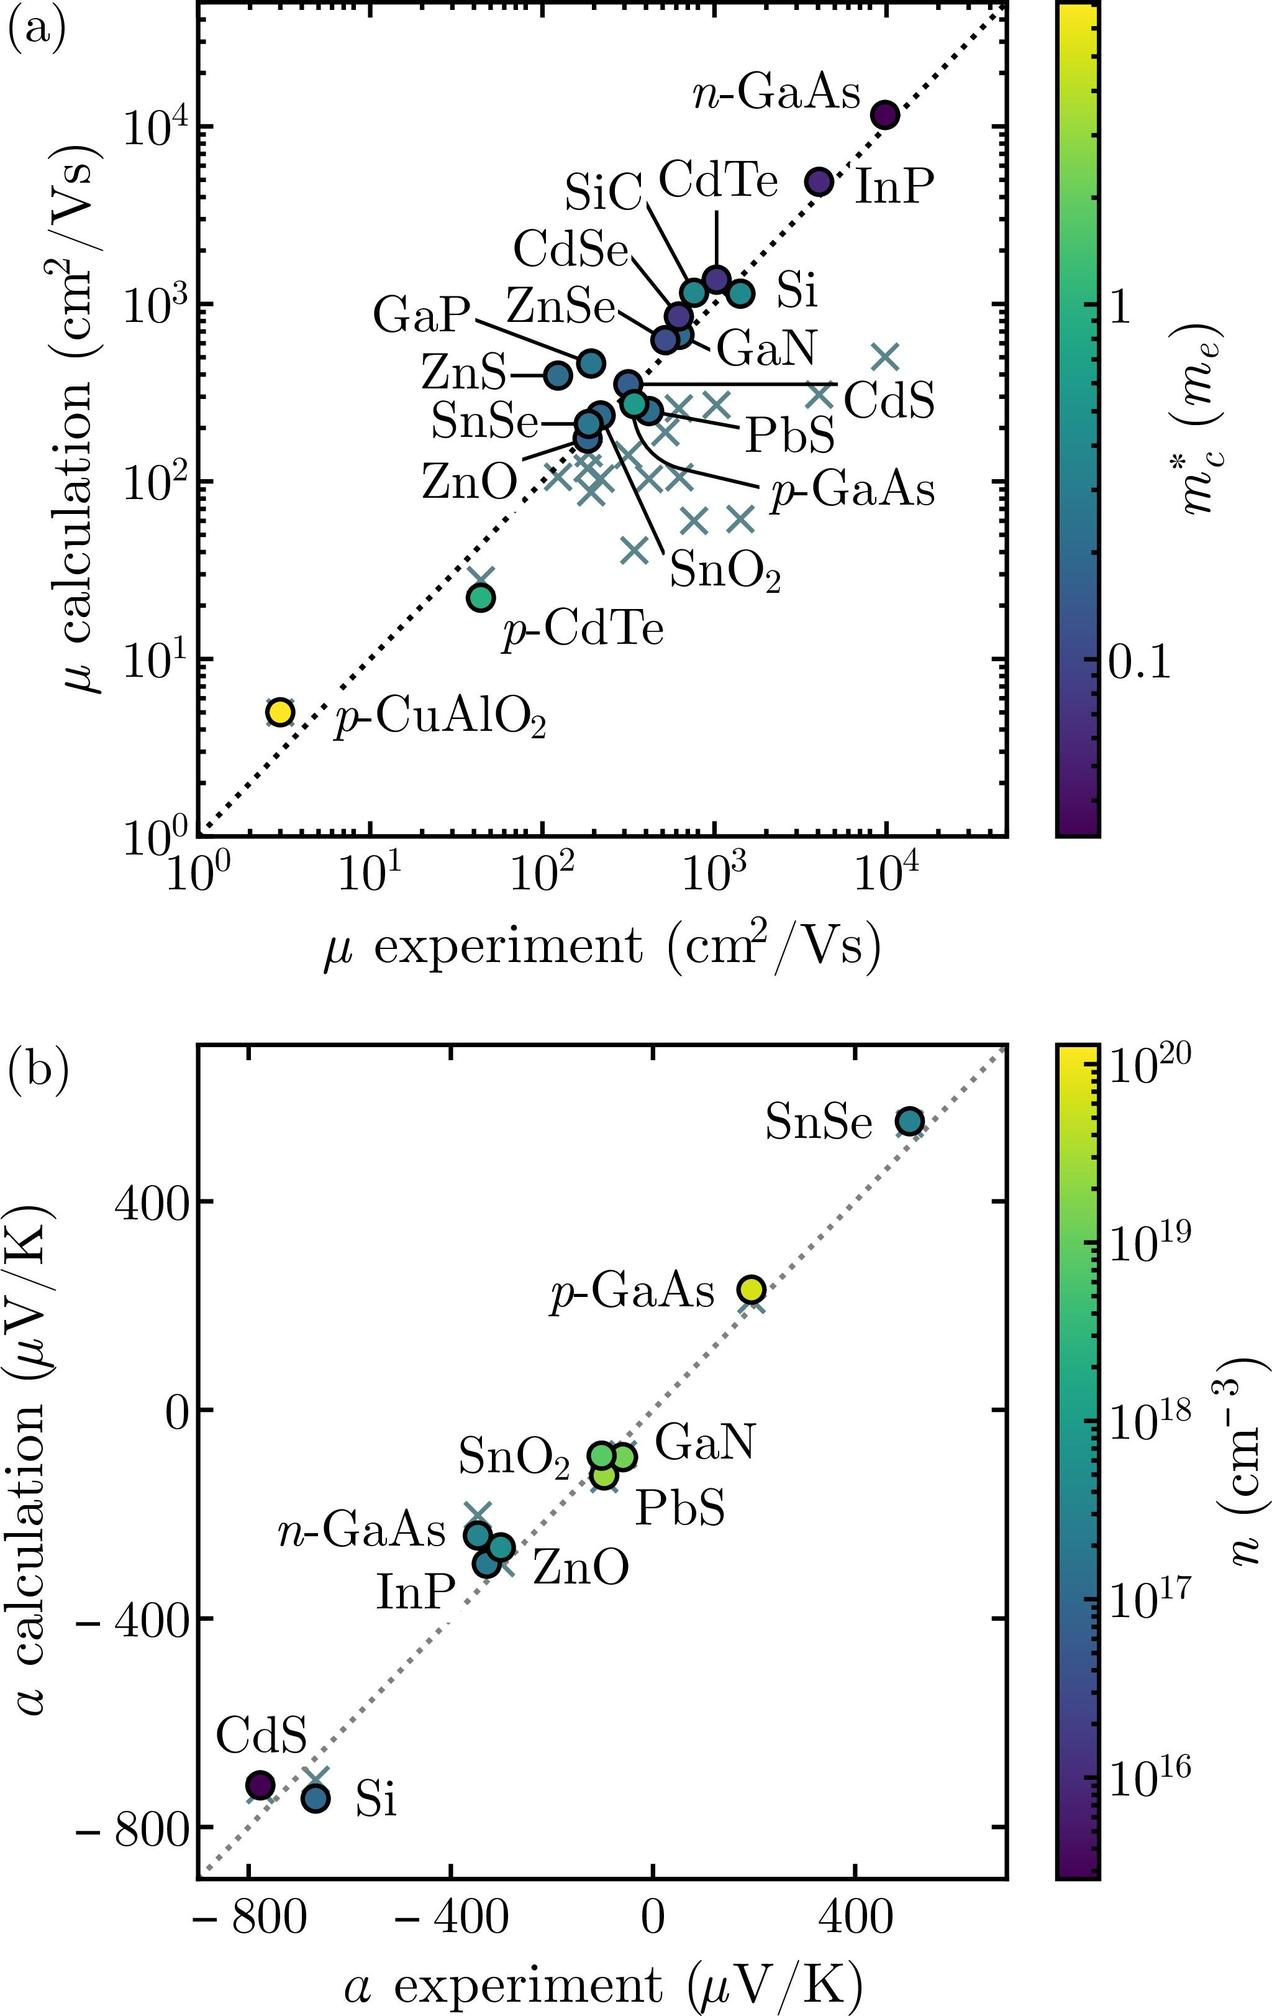What does the position of a material with respect to the dashed line in Figure (b) indicate? In Figure (b), the dashed line represents the line of agreement where the experimental Seebeck coefficient (\( \alpha_{experiment} \)) matches the theoretical calculation (\( \alpha_{calculation} \)). Materials located on this line would have experimental values that align perfectly with their theoretical predictions. The position of a material either above or below this line indicates a deviation between the experimental and theoretical values. For example, materials above the line have a higher experimental Seebeck coefficient than predicted theoretically, while those below the line have a lower experimental value than their calculated counterpart. 